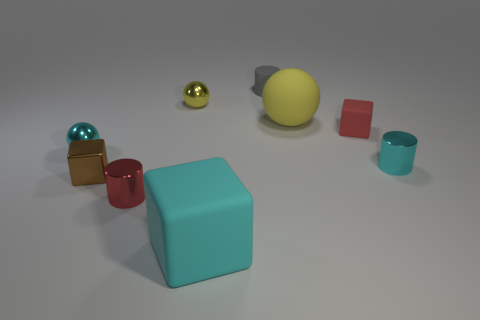Is there a pattern to the arrangement of the objects? There doesn't seem to be a strict pattern; the objects are scattered across the surface with varying distances between them, creating an impression of randomness. 